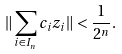<formula> <loc_0><loc_0><loc_500><loc_500>\| \sum _ { i \in I _ { n } } c _ { i } z _ { i } \| < \frac { 1 } { 2 ^ { n } } .</formula> 